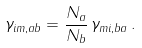Convert formula to latex. <formula><loc_0><loc_0><loc_500><loc_500>\gamma _ { i m , a b } = \frac { N _ { a } } { N _ { b } } \, \gamma _ { m i , b a } \, .</formula> 